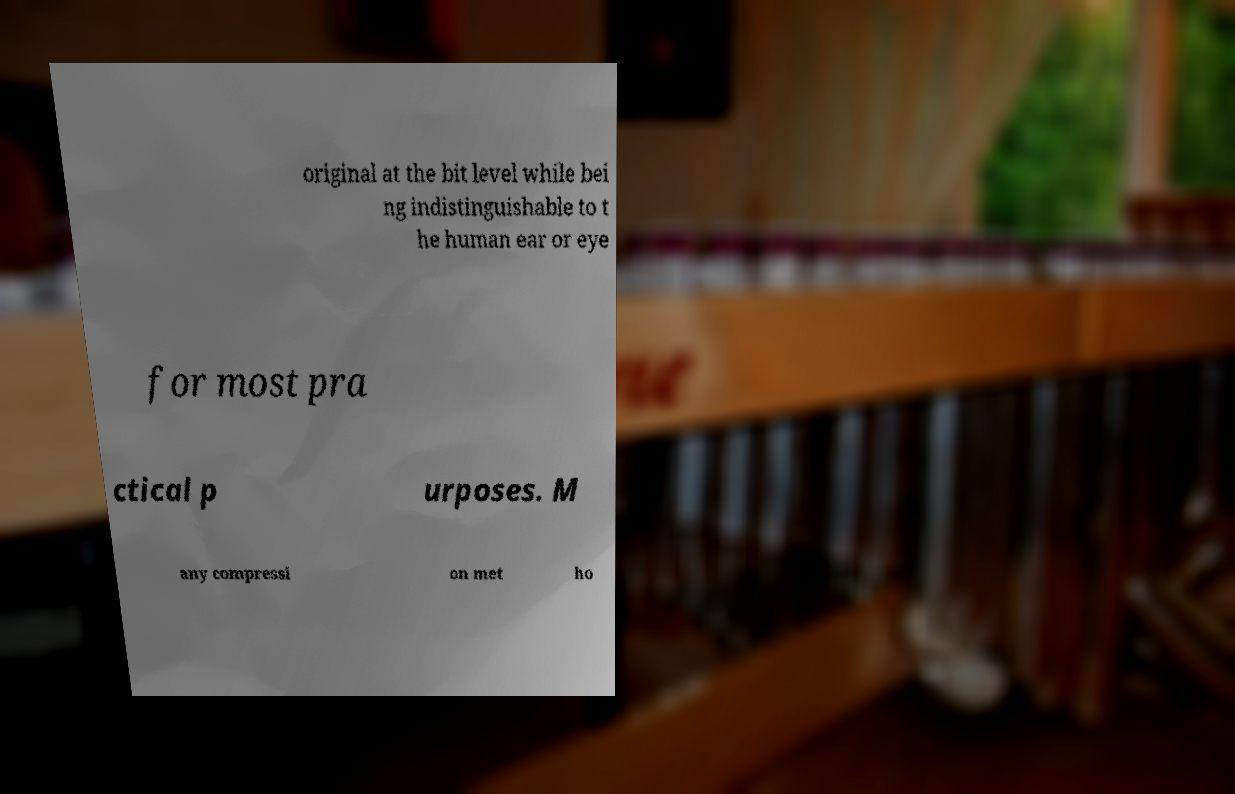Can you read and provide the text displayed in the image?This photo seems to have some interesting text. Can you extract and type it out for me? original at the bit level while bei ng indistinguishable to t he human ear or eye for most pra ctical p urposes. M any compressi on met ho 